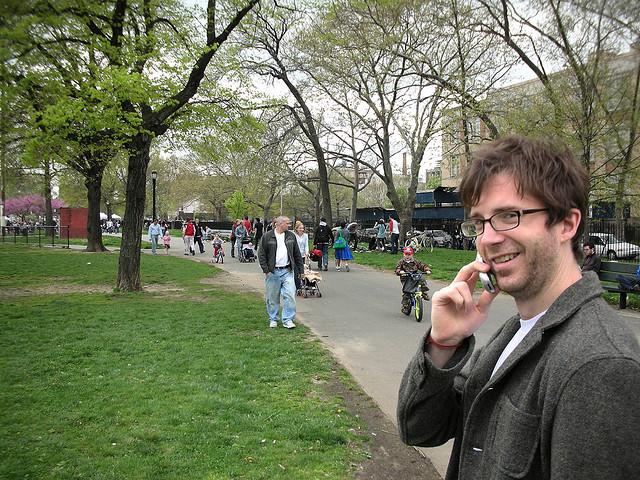What is he carrying?
Keep it brief. Phone. Are his eyes open?
Give a very brief answer. Yes. What is the man talking to?
Short answer required. Cell phone. What does the man have in his hands?
Short answer required. Phone. Is this a zoo?
Be succinct. No. Has the wedding occurred?
Short answer required. No. Are the bikers cycling away from or towards the boy?
Write a very short answer. Towards. What kind of blossoms are on the tree?
Answer briefly. None. What kind of tree is this?
Quick response, please. Oak. Who is wearing a blue skirt?
Keep it brief. Woman in background on right side of path. Are there leaves on the trees?
Answer briefly. Yes. Is it sunny?
Give a very brief answer. No. Is the man holding pizza?
Give a very brief answer. No. Is the man eating pizza?
Keep it brief. No. Where is the bench?
Be succinct. Behind man. What season is it?
Concise answer only. Spring. 